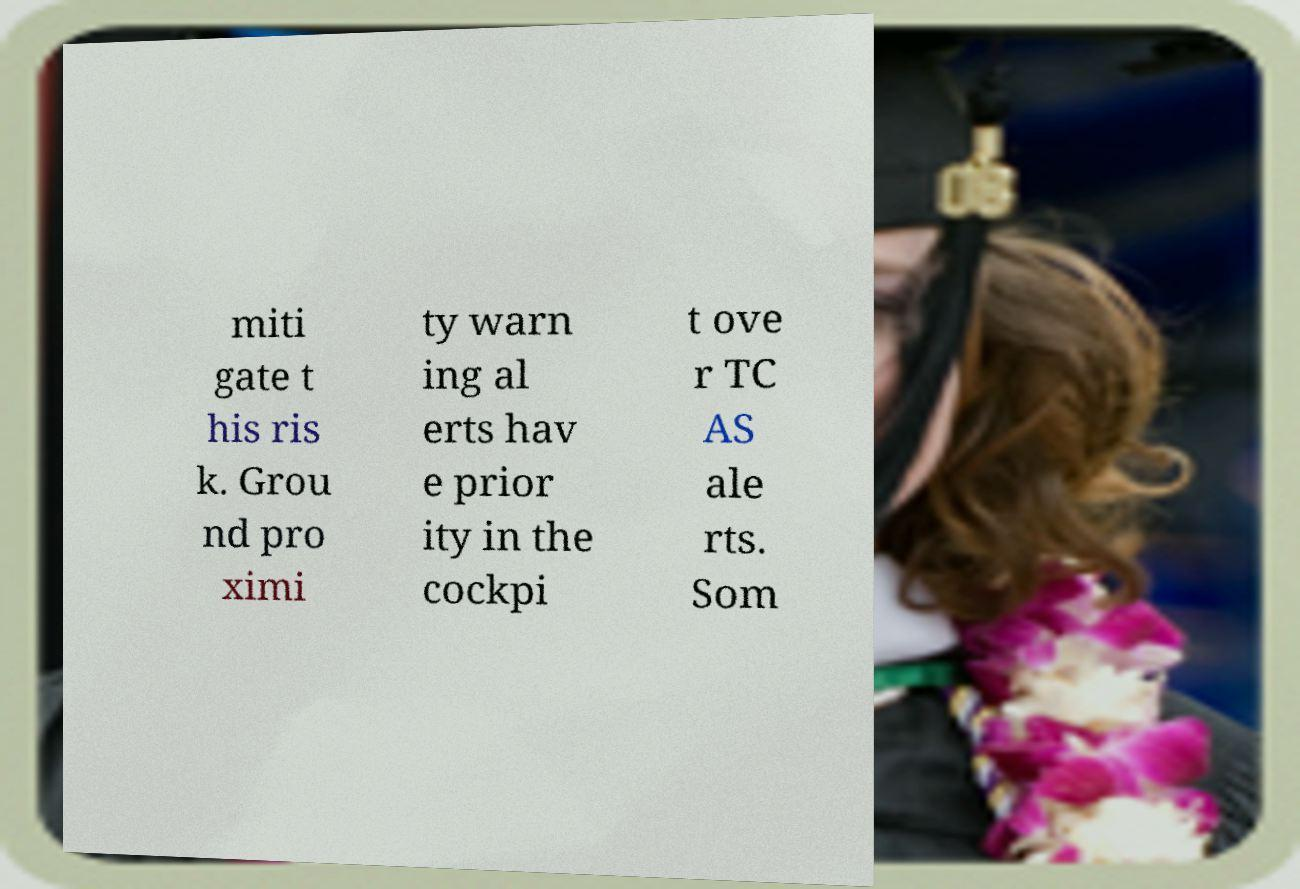Could you extract and type out the text from this image? miti gate t his ris k. Grou nd pro ximi ty warn ing al erts hav e prior ity in the cockpi t ove r TC AS ale rts. Som 